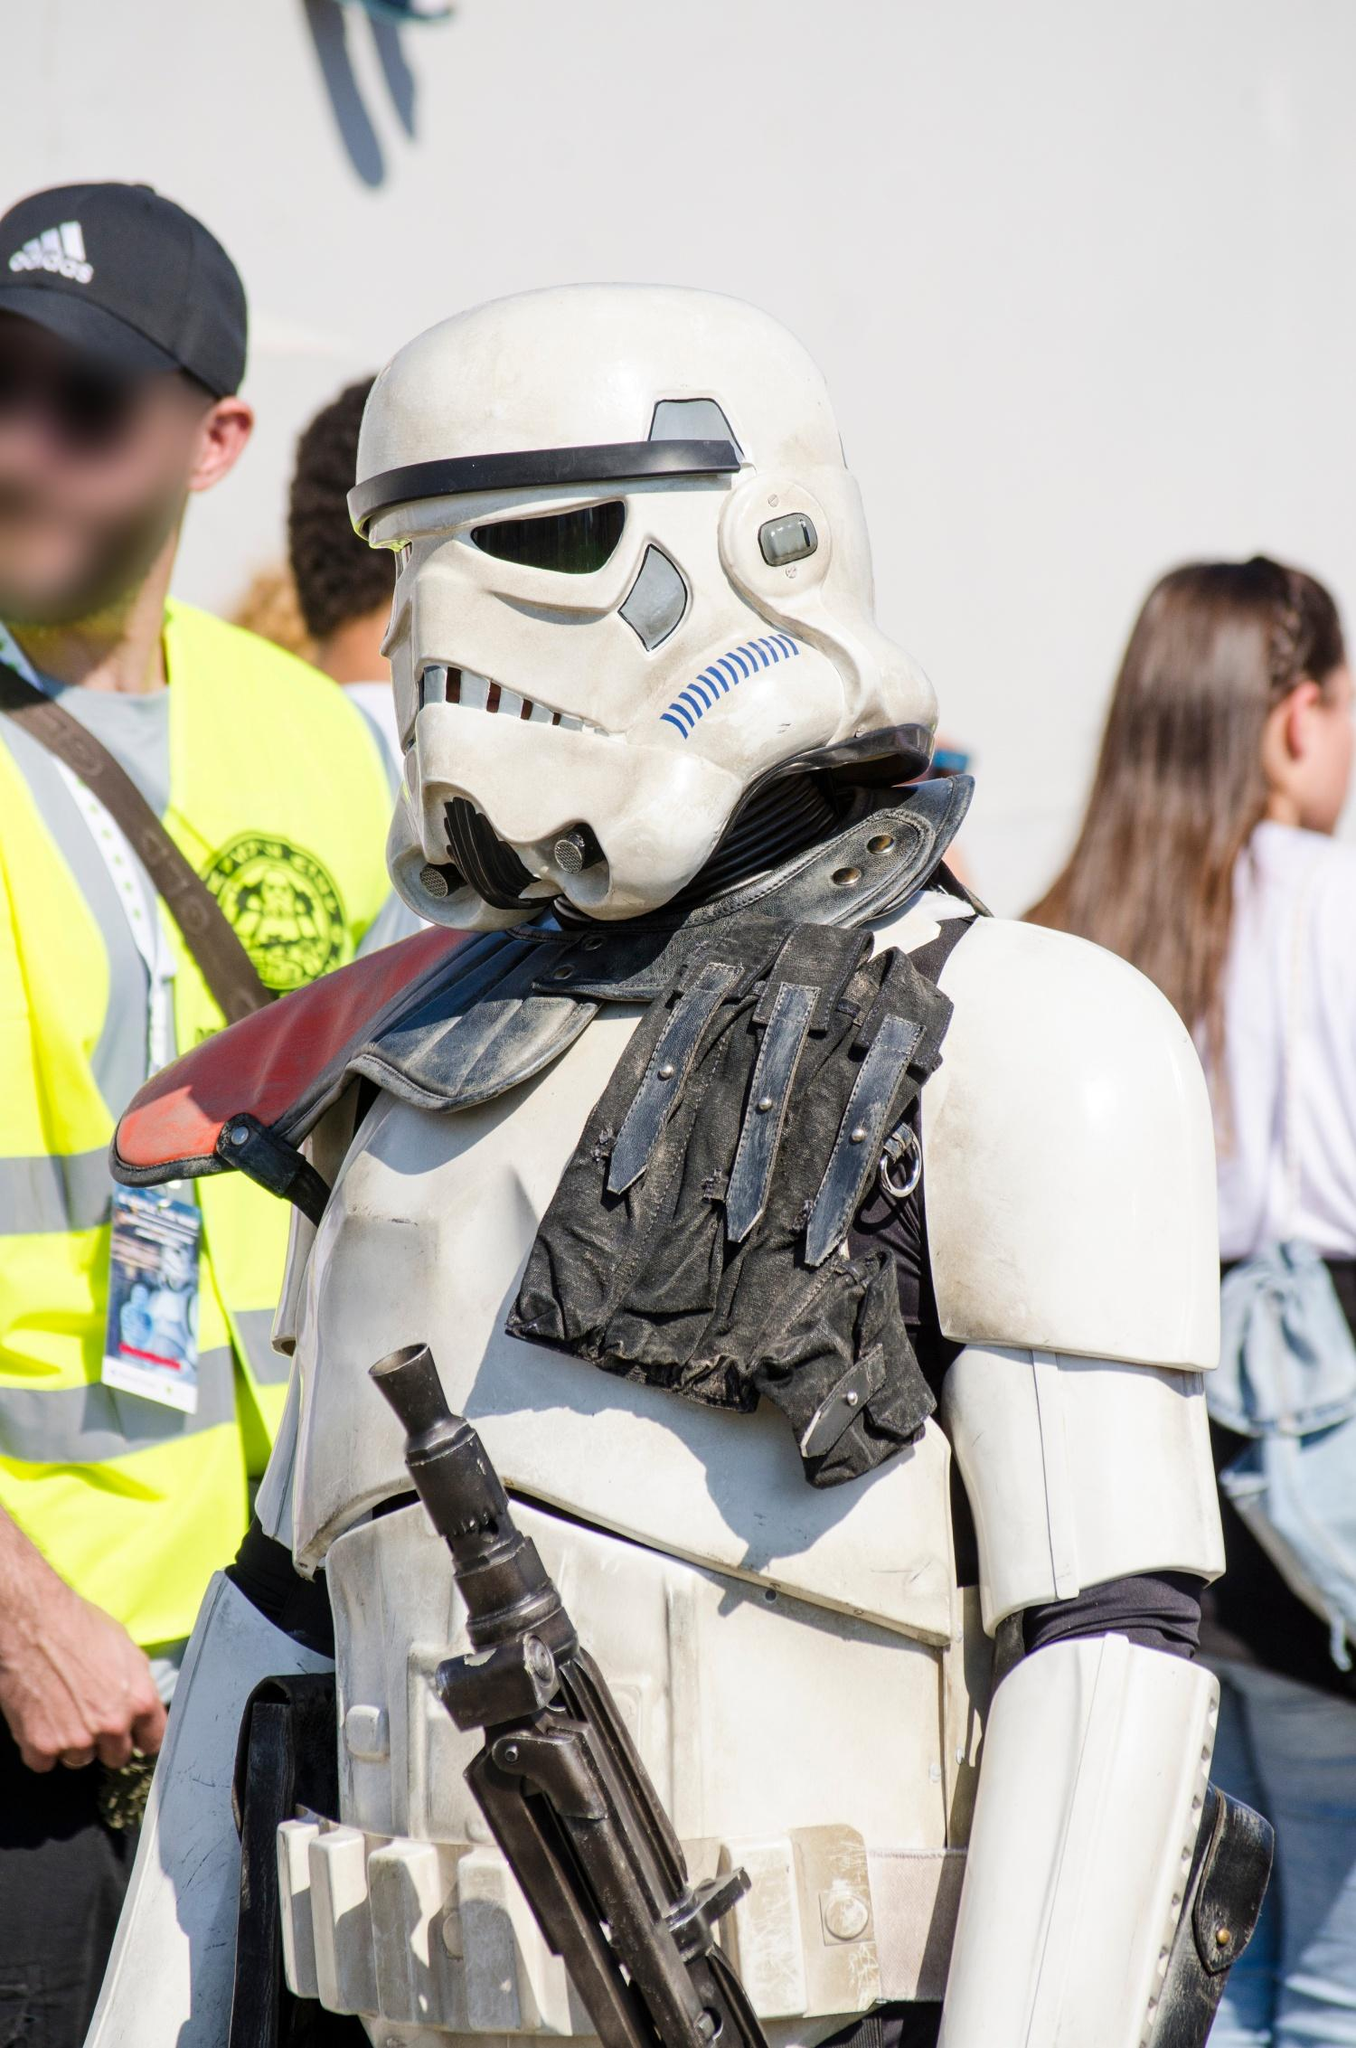Imagine if the person in the Stormtrooper costume enters a surprise costume contest at the event. How would they react to winning first place? Describe the scene. As the announcement of the first-place winner is made, the crowd erupts into applause and cheers when the name of the Stormtrooper is called. The person in the costume, visibly surprised, steps forward to the stage. The bright lights shine down on them, revealing the intricate details of their armor. The host hands over a large trophy, gleaming under the spotlights, and a sash that reads 'Best Costume'. The Stormtrooper raises the trophy high, and although the helmet hides their face, the joy and excitement are palpable from their body language.

Fans gather around the stage, eager to take photographs with the winner. The Stormtrooper remains gracious, posing for pictures and interacting with the audience, thanking them for their support. The event organizers applaud their craftsmanship and dedication to the character, adding a fitting end to the thrilling competition. 